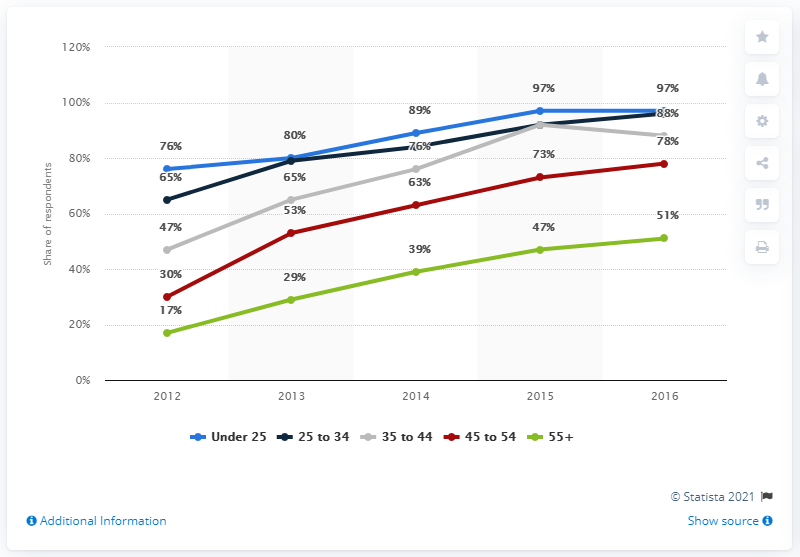Point out several critical features in this image. In 2016, the penetration rate of smartphones in Ireland was 97%. In 2016, the penetration rate for internet users aged 55 and older in Ireland was 51%. 